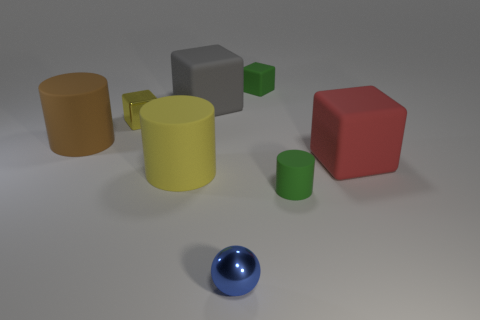Subtract 1 cubes. How many cubes are left? 3 Subtract all brown balls. Subtract all cyan blocks. How many balls are left? 1 Add 2 large cyan cylinders. How many objects exist? 10 Subtract all cylinders. How many objects are left? 5 Add 5 tiny cylinders. How many tiny cylinders exist? 6 Subtract 1 yellow cylinders. How many objects are left? 7 Subtract all green metallic objects. Subtract all shiny blocks. How many objects are left? 7 Add 3 tiny shiny objects. How many tiny shiny objects are left? 5 